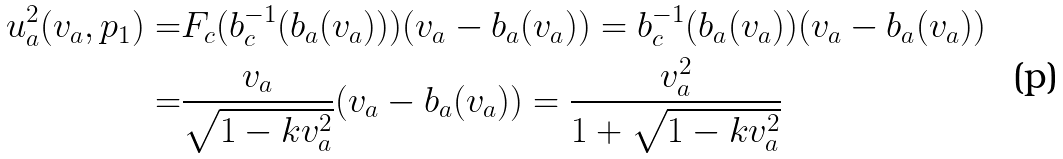<formula> <loc_0><loc_0><loc_500><loc_500>u _ { a } ^ { 2 } ( v _ { a } , p _ { 1 } ) = & F _ { c } ( b _ { c } ^ { - 1 } ( b _ { a } ( v _ { a } ) ) ) ( v _ { a } - b _ { a } ( v _ { a } ) ) = b _ { c } ^ { - 1 } ( b _ { a } ( v _ { a } ) ) ( v _ { a } - b _ { a } ( v _ { a } ) ) \\ = & \frac { v _ { a } } { \sqrt { 1 - k v _ { a } ^ { 2 } } } ( v _ { a } - b _ { a } ( v _ { a } ) ) = \frac { v _ { a } ^ { 2 } } { 1 + \sqrt { 1 - k v _ { a } ^ { 2 } } }</formula> 